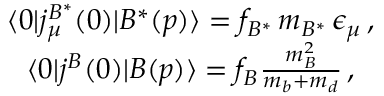Convert formula to latex. <formula><loc_0><loc_0><loc_500><loc_500>\begin{array} { c } { { \langle 0 | j _ { \mu } ^ { B ^ { \ast } } ( 0 ) | B ^ { \ast } ( p ) \rangle = f _ { B ^ { \ast } } \, m _ { B ^ { \ast } } \, \epsilon _ { \mu } \, , } } \\ { { \langle 0 | j ^ { B } ( 0 ) | B ( p ) \rangle = f _ { B } { \frac { m _ { B } ^ { 2 } } { m _ { b } + m _ { d } } } \, , } } \end{array}</formula> 